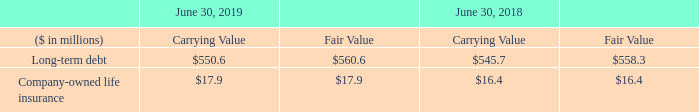The carrying amounts of other financial instruments not listed in the table below approximate fair value due to the short-term nature of these items. The carrying amounts and estimated fair values of the Company’s financial instruments not recorded at fair value in the financial statements were as follows:
The fair values of long-term debt as of June 30, 2019 and June 30, 2018 were determined by using current interest rates for debt with terms and maturities similar to the Company’s existing debt arrangements and accordingly would be classified as Level 2 inputs in the fair value hierarchy.
The carrying amount of company-owned life insurance reflects cash surrender values based upon the market values of underlying securities, using Level 2 inputs, net of any outstanding policy loans. The carrying value associated with the cash surrender value of these policies is recorded in other assets in the accompanying consolidated balance sheets.
For purposes of performing Step 1 of goodwill impairment testing, the Company uses certain nonrecurring fair value measurements using significant unobservable inputs (Level 3). Fair value of each reporting unit for purposes of the goodwill impairment test is based on a weighting of an income approach and a market approach. Under the income approach, fair value is determined based on a discounted cash flow analysis that uses estimates of cash flows discounted to present value using rates commensurate with the risks associated with those cash flows. Under the market approach, a market-based value is derived by relating multiples for earnings and cash flow measures for a group of comparable public companies to the same measure for each reporting unit to estimate fair value. The assumptions used by the Company to determine fair value of the reporting units are similar to those that would be used by market participants performing valuations.
What is the carrying value of long-term debt in 2019?
Answer scale should be: million. $550.6. What is the fair value of long-term debt in 2018?
Answer scale should be: million. $558.3. In which years is the carrying and fair values of long-term debt provided? 2019, 2018. In which year was the fair value of Company-owned life insurance larger? 17.9>16.4
Answer: 2019. What was the change in the fair value of Company-owned life insurance in 2019 from 2018?
Answer scale should be: million. 17.9-16.4
Answer: 1.5. What was the percentage change in the fair value of Company-owned life insurance in 2019 from 2018?
Answer scale should be: percent. (17.9-16.4)/16.4
Answer: 9.15. 